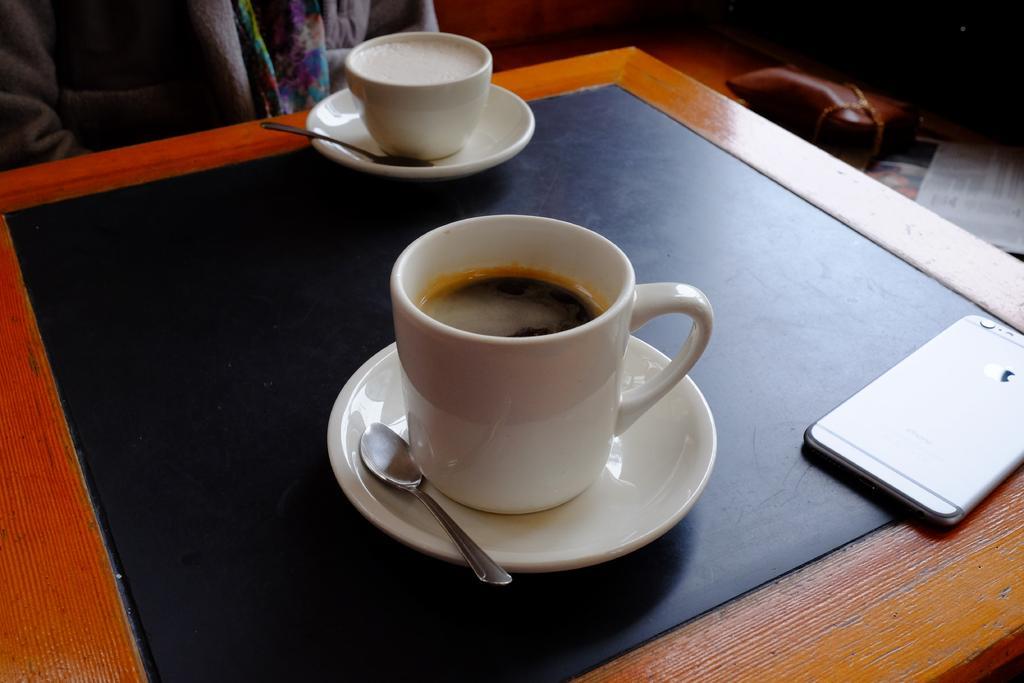Could you give a brief overview of what you see in this image? In this image I can see two cups with saucers, spoons, also there is a mobile, which are there on the table. In the top left corner there is a person. In the top right corner there is a paper and a bag. 